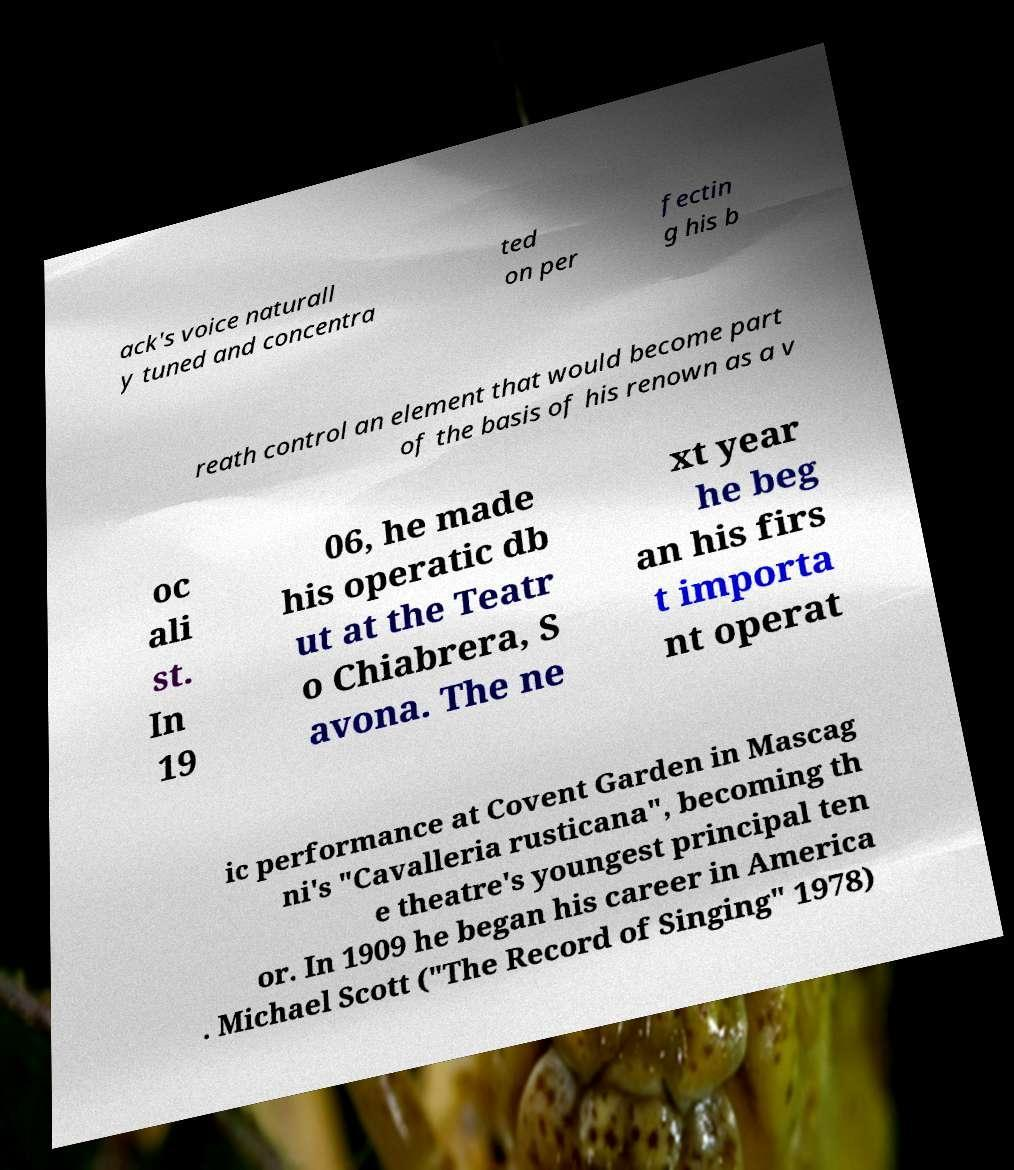There's text embedded in this image that I need extracted. Can you transcribe it verbatim? ack's voice naturall y tuned and concentra ted on per fectin g his b reath control an element that would become part of the basis of his renown as a v oc ali st. In 19 06, he made his operatic db ut at the Teatr o Chiabrera, S avona. The ne xt year he beg an his firs t importa nt operat ic performance at Covent Garden in Mascag ni's "Cavalleria rusticana", becoming th e theatre's youngest principal ten or. In 1909 he began his career in America . Michael Scott ("The Record of Singing" 1978) 